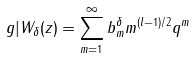Convert formula to latex. <formula><loc_0><loc_0><loc_500><loc_500>g | W _ { \delta } ( z ) = \sum _ { m = 1 } ^ { \infty } b _ { m } ^ { \delta } m ^ { ( l - 1 ) / 2 } q ^ { m }</formula> 